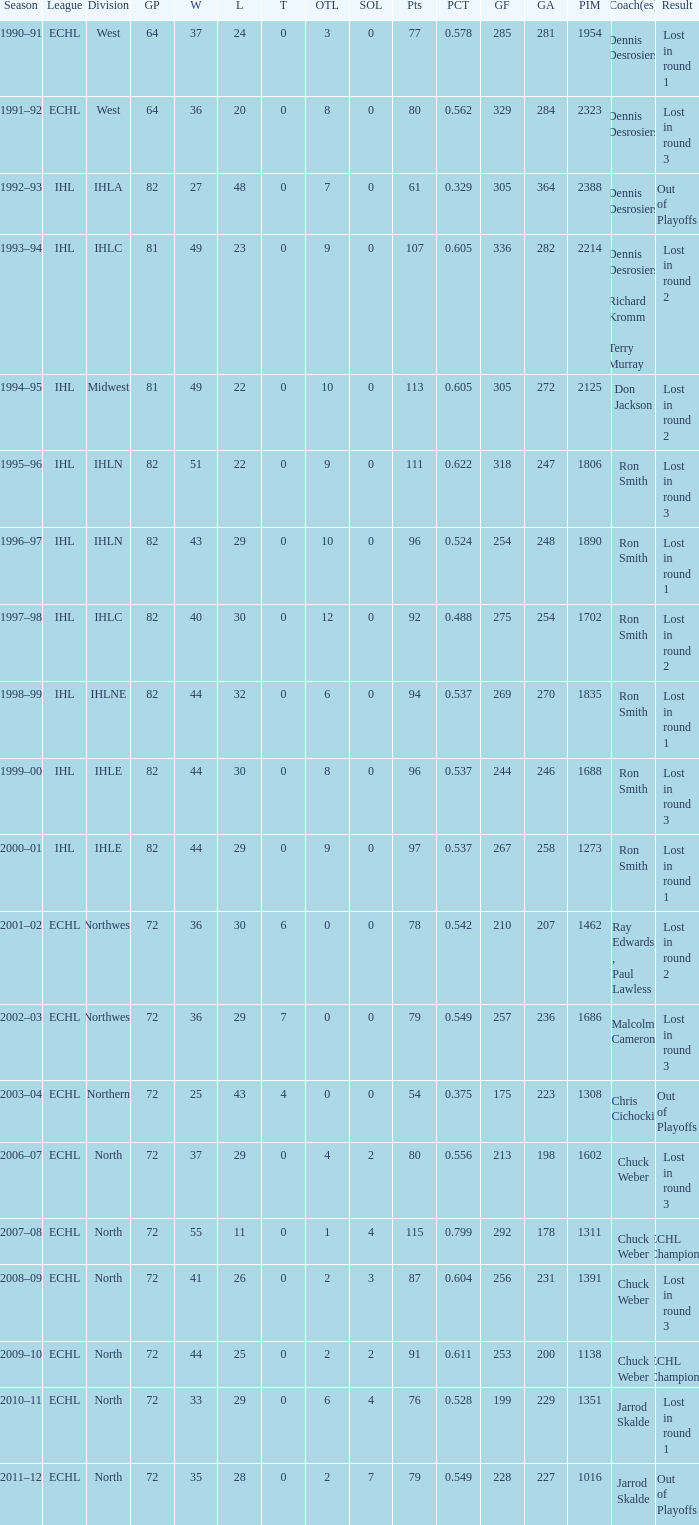What was the season where the team reached a GP of 244? 1999–00. 